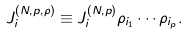Convert formula to latex. <formula><loc_0><loc_0><loc_500><loc_500>J ^ { ( N , p , \rho ) } _ { i } \equiv J ^ { ( N , p ) } _ { i } \rho _ { i _ { 1 } } \cdots \rho _ { i _ { p } } .</formula> 